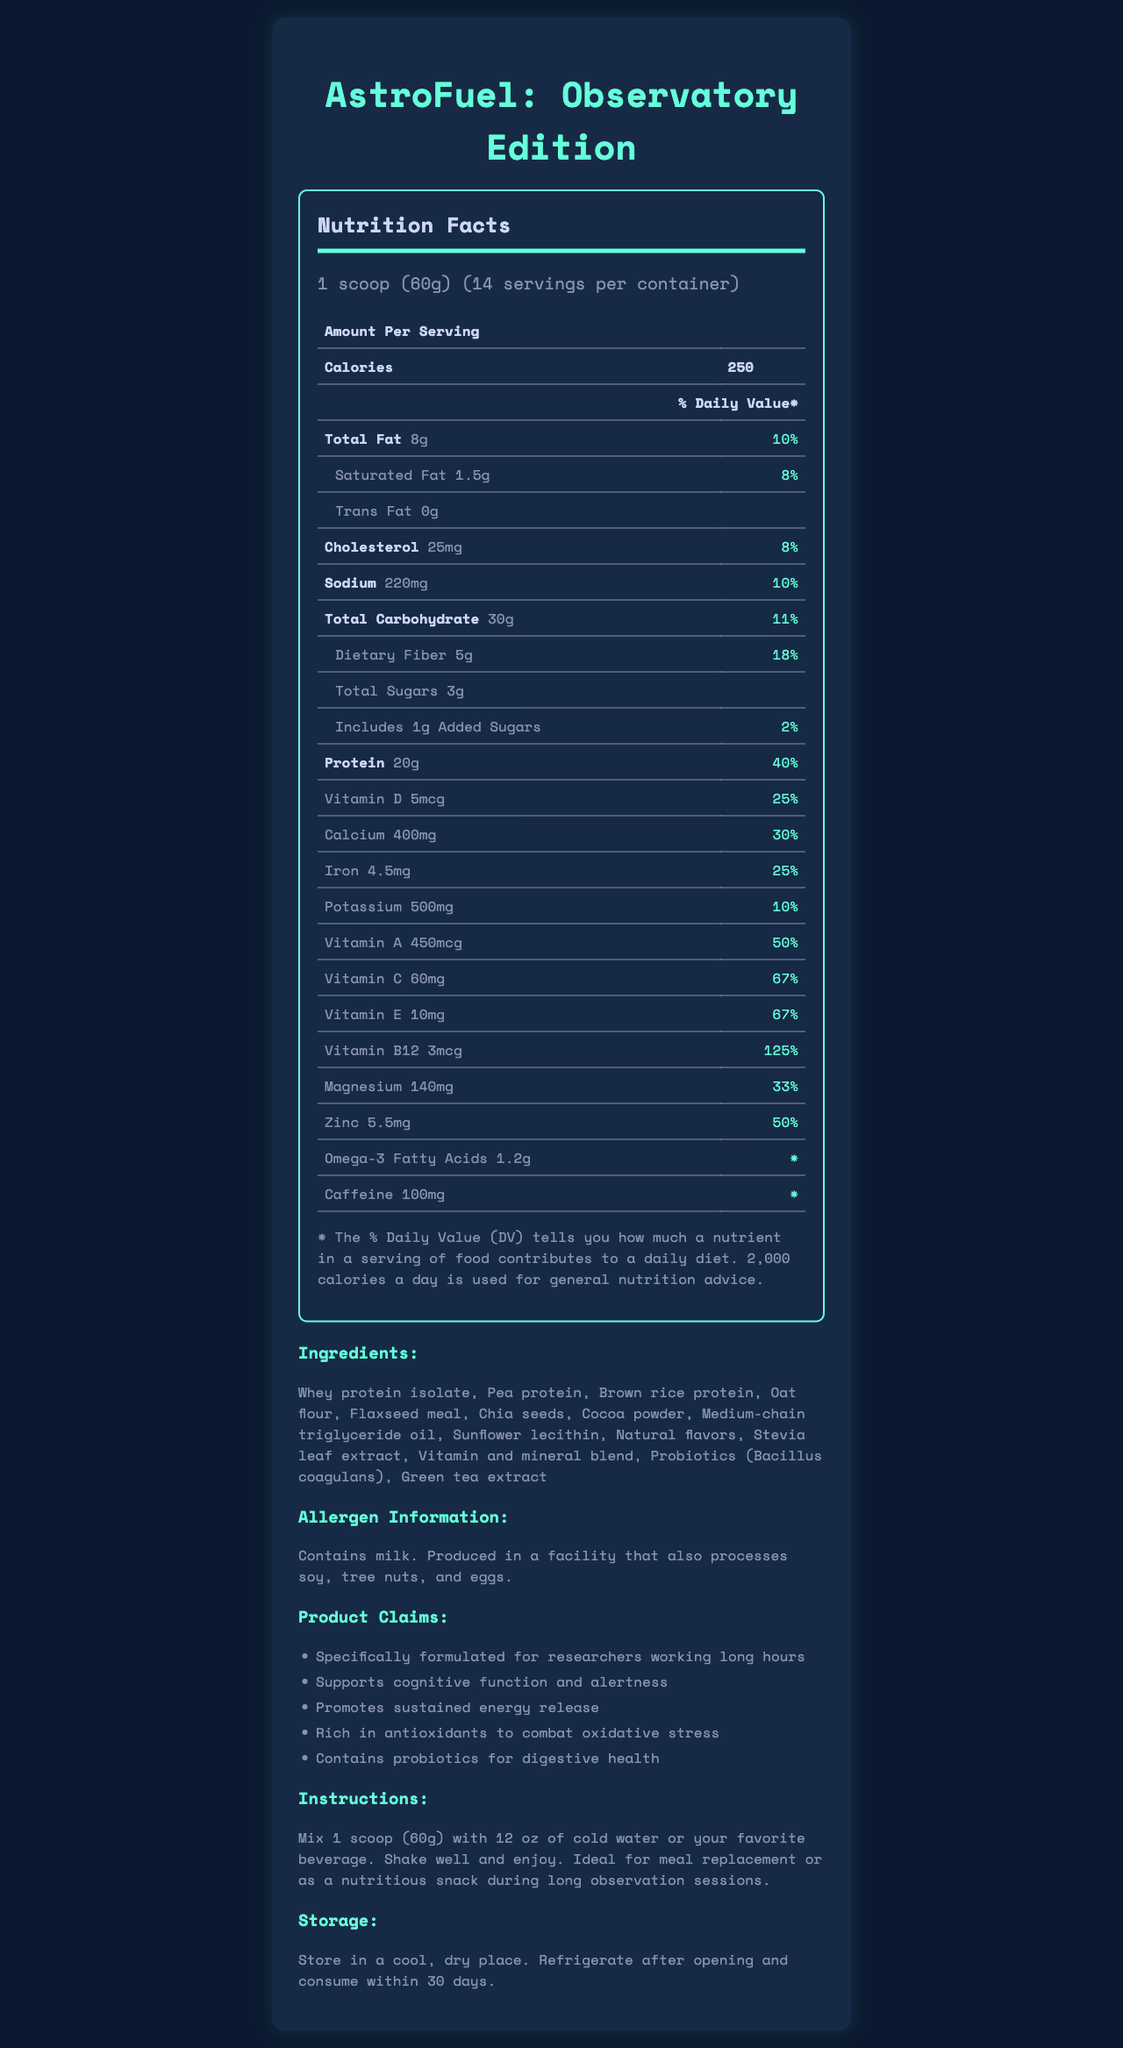what is the serving size of AstroFuel: Observatory Edition? The serving size is mentioned at the top of the Nutrition Facts section as "1 scoop (60g)".
Answer: 1 scoop (60g) how many calories are in one serving? The number of calories is listed clearly under the "Amount Per Serving" section as 250.
Answer: 250 what is the daily value percentage of protein per serving? The percentage daily value for protein is listed as 40% next to the amount of protein.
Answer: 40% list the top three ingredients in AstroFuel: Observatory Edition. The ingredients are listed in a sequence, and the top three are "Whey protein isolate", "Pea protein", and "Brown rice protein".
Answer: Whey protein isolate, Pea protein, Brown rice protein how many servings are in each container? The number of servings per container is stated right under the serving size as 14.
Answer: 14 does AstroFuel contain any allergens? Under the "Allergen Information" section, it mentions the product contains milk and is produced in a facility that also processes soy, tree nuts, and eggs.
Answer: Yes how much caffeine is in one serving? The amount of caffeine per serving is listed under the nutrition table as 100mg.
Answer: 100mg what should you do after opening the container? The storage instructions mention to refrigerate after opening and consume within 30 days.
Answer: Refrigerate and consume within 30 days how much dietary fiber does one serving contain? The amount of dietary fiber per serving is found in the nutrition table as 5g.
Answer: 5g what is the percentage daily value of Vitamin C per serving? The daily value percentage for Vitamin C is mentioned in the nutrition table as 67%.
Answer: 67% which nutrient has the highest % Daily Value in one serving? The highest % Daily Value listed is for Vitamin B12, which is 125%.
Answer: Vitamin B12 what is the total carbohydrate content per serving? A. 25g B. 30g C. 35g The total carbohydrate amount per serving is listed as 30g.
Answer: B which of the following is NOT mentioned as an ingredient? I. Whey protein isolate II. Soy protein III. Flaxseed meal IV. Cocoa powder Soy protein is not mentioned in the ingredient list; the other options are.
Answer: II can AstroFuel be used as a meal replacement? The instructions indicate that AstroFuel is ideal for meal replacement or as a nutritious snack.
Answer: Yes does the product support cognitive function and alertness? One of the product claims states it supports cognitive function and alertness.
Answer: Yes summarize the main idea of the document. The document includes a comprehensive Nutrition Facts table, a list of ingredients, allergen warnings, various health claims, how to prepare the shake, and storage instructions, emphasizing its suitability for long-duration observational research.
Answer: The document provides detailed nutritional information, ingredients, allergen information, product claims, preparation instructions, and storage guidelines for AstroFuel: Observatory Edition, a nutrient-dense meal replacement shake tailored for researchers working long hours at remote observatories. can you determine the exact shelf life of the unopened product from the document? The document provides storage instructions for after opening but does not specify the shelf life for an unopened product.
Answer: Not enough information 